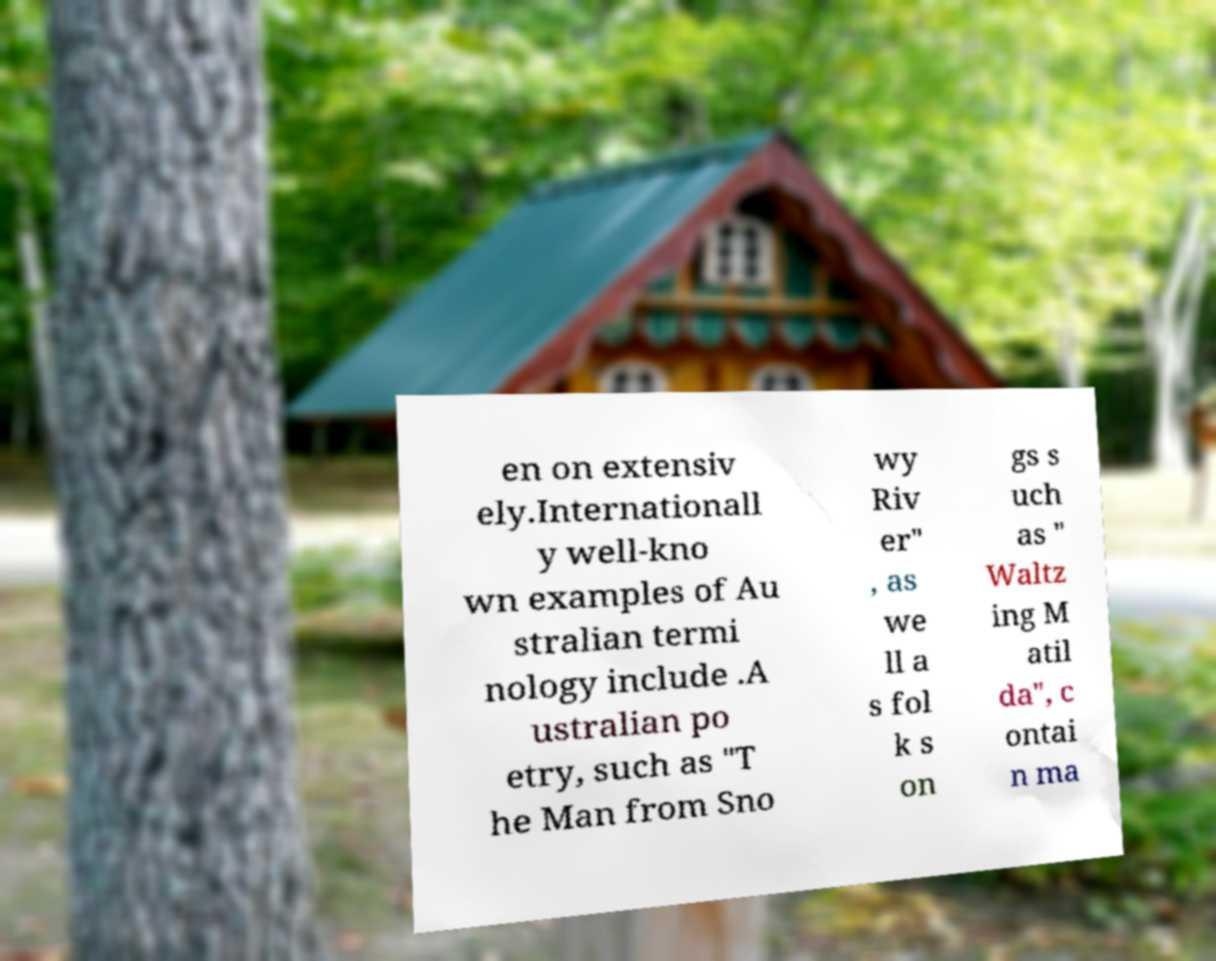Could you extract and type out the text from this image? en on extensiv ely.Internationall y well-kno wn examples of Au stralian termi nology include .A ustralian po etry, such as "T he Man from Sno wy Riv er" , as we ll a s fol k s on gs s uch as " Waltz ing M atil da", c ontai n ma 